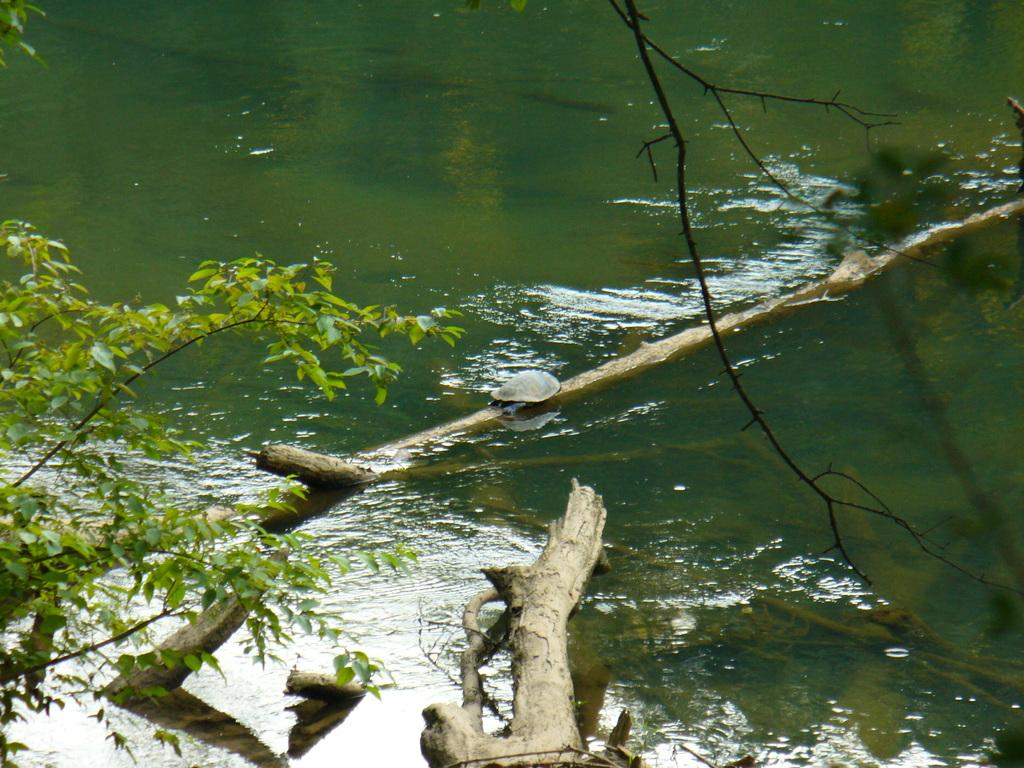What animal is on the wood in the image? There is a tortoise on the wood in the image. What can be seen on the left side of the image? There is a branch of a tree on the left side of the image. What natural element is visible in the image? Water is visible in the image. What is the price of the ray in the image? There is no ray present in the image, so it is not possible to determine its price. 